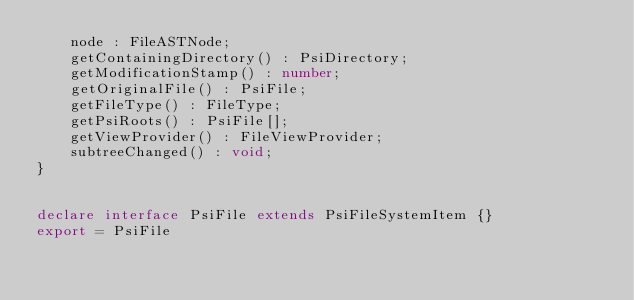Convert code to text. <code><loc_0><loc_0><loc_500><loc_500><_TypeScript_>	node : FileASTNode;
	getContainingDirectory() : PsiDirectory;
	getModificationStamp() : number;
	getOriginalFile() : PsiFile;
	getFileType() : FileType;
	getPsiRoots() : PsiFile[];
	getViewProvider() : FileViewProvider;
	subtreeChanged() : void;
}


declare interface PsiFile extends PsiFileSystemItem {}
export = PsiFile
</code> 